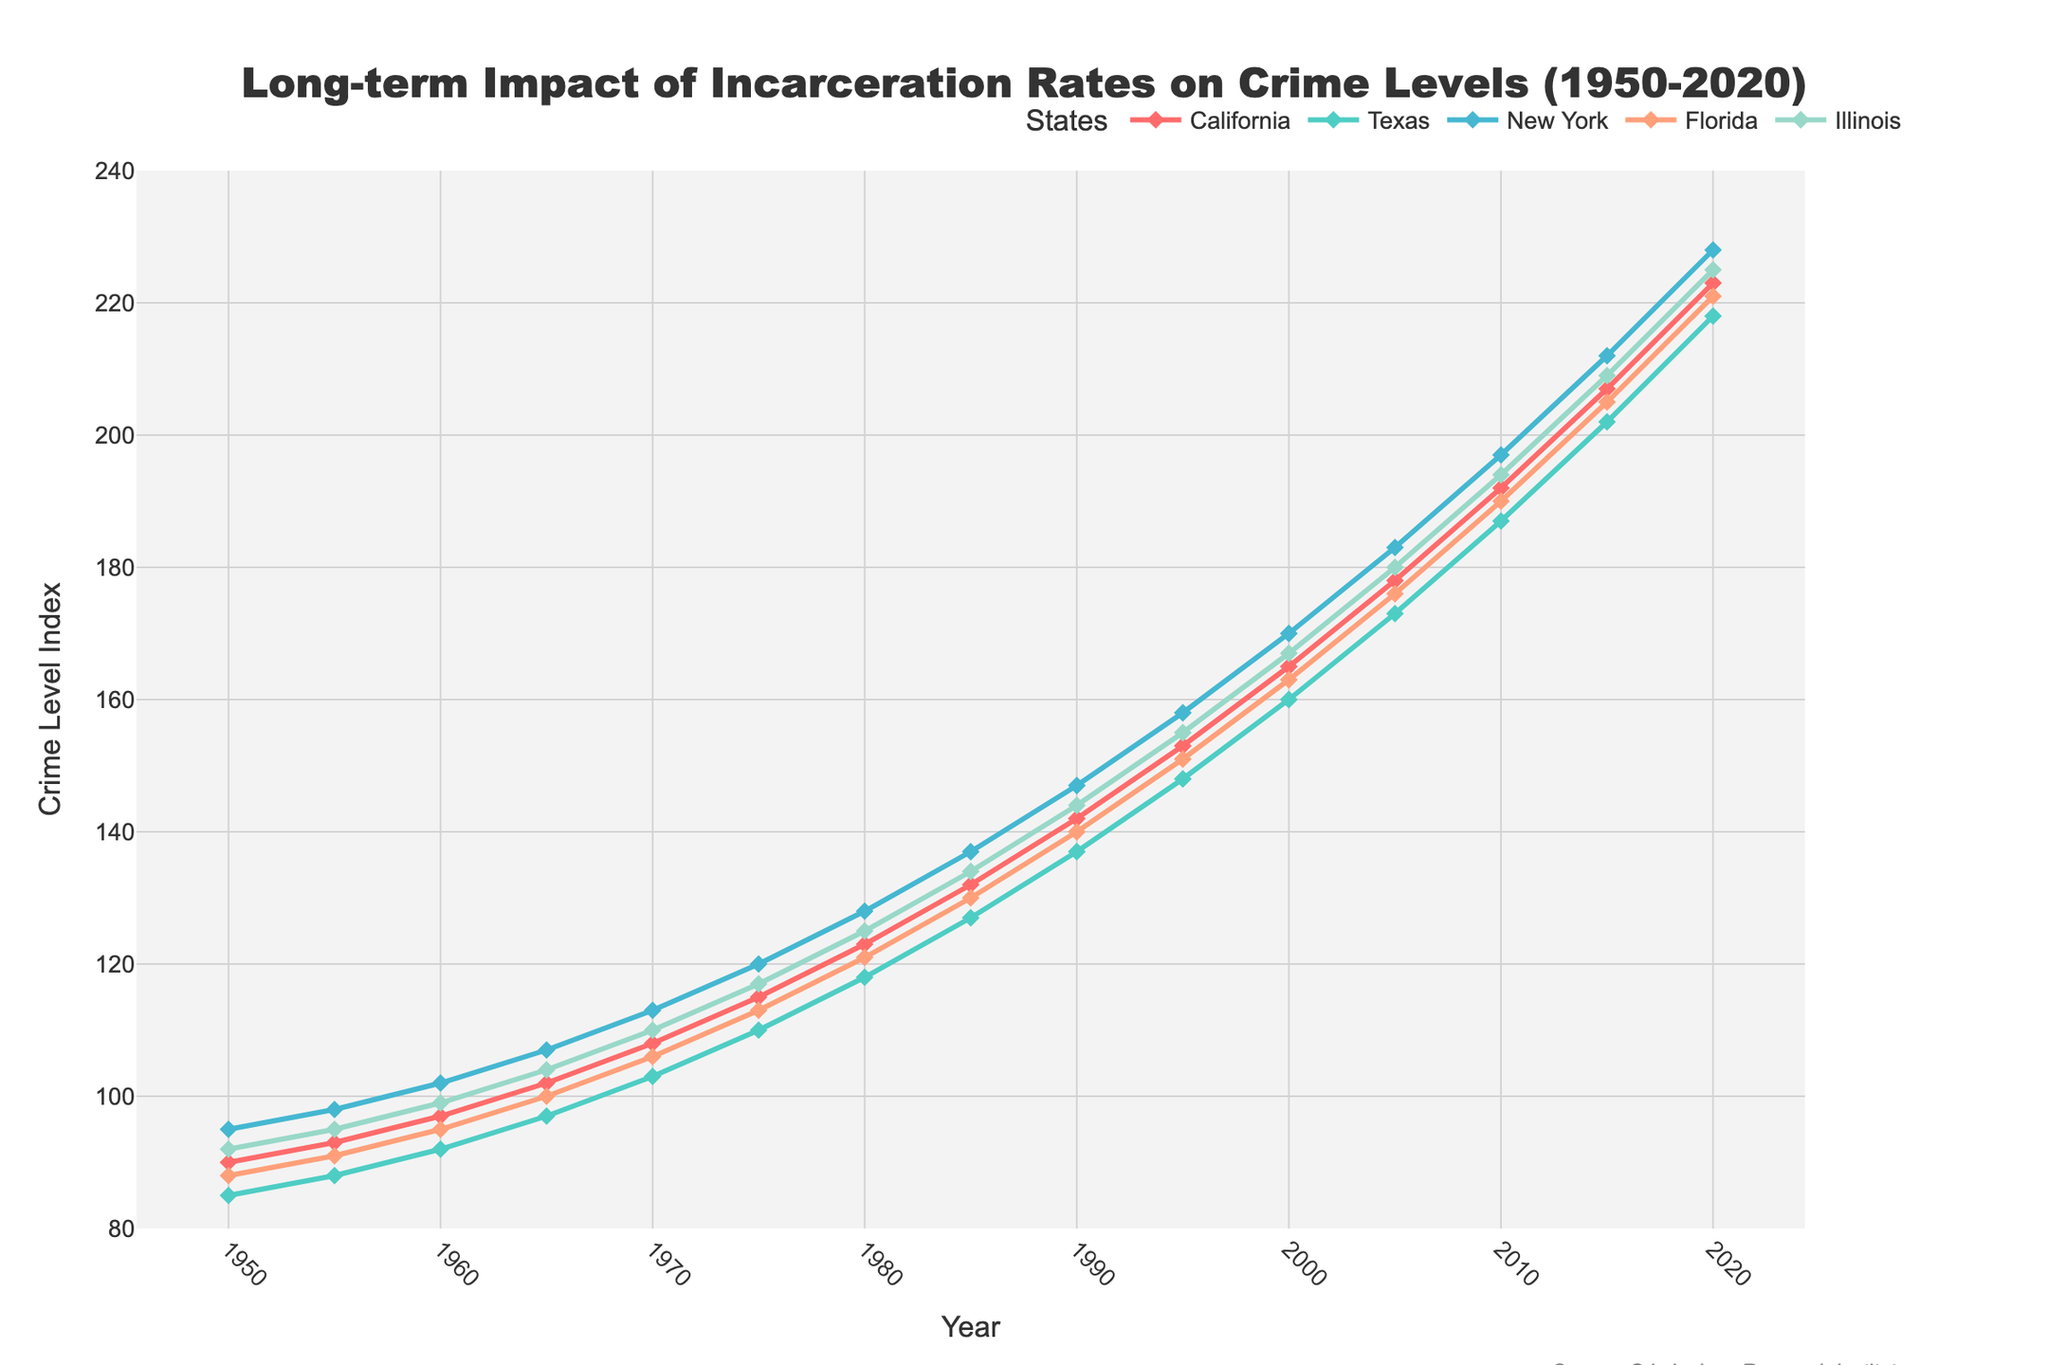What was the crime level in Texas in the year 2000? To determine the crime level in Texas in the year 2000, locate '2000' on the x-axis and find where the Texas line intersects this year. From the data, it intersects at 160.
Answer: 160 Which state had the highest increase in crime levels from 1950 to 2020? To find which state had the highest increase in crime levels, subtract the crime levels of each state in 1950 from the levels in 2020. The differences are: California (223-90=133), Texas (218-85=133), New York (228-95=133), Florida (221-88=133), Illinois (225-92=133). All states increased by the same amount, so multiple states tie.
Answer: California, Texas, New York, Florida, Illinois (tie) What is the average crime level across all states in 1980? To find the average crime level in 1980, sum the crime levels of all states in 1980 and divide by the number of states. The levels are: California (123), Texas (118), New York (128), Florida (121), Illinois (125). Sum: 123 + 118 + 128 + 121 + 125 = 615. Average: 615 / 5 = 123.
Answer: 123 Which state had the steeper increase in crime levels between 1965 and 1975, California or New York? To determine which state had a steeper increase, calculate the difference in crime levels between 1965 and 1975 for both states. California: 115 - 102 = 13. New York: 120 - 107 = 13. Both states had the same increase, so they had equal steepness.
Answer: Both equal What color represents Florida's crime level line? Identify the color of Florida's line in the legend of the chart. Florida is represented by an orange color.
Answer: Orange Compare the crime level trends between Illinois and New York from 1970 to 2020. Which state experienced more fluctuations? To compare the trends, observe the line patterns for Illinois and New York. New York’s line appears to have more fluctuations than Illinois's from 1970 to 2020, as New York has more distinct upward and downward movements.
Answer: New York What is the combined crime level for California and Texas in 1995? To find the combined crime level, add the crime levels of California and Texas in 1995. California: 153, Texas: 148. Combined: 153 + 148 = 301.
Answer: 301 Between the years 1985 and 2000, which state showed the least change in crime level? To determine the least change, find the difference in crime levels between 1985 and 2000 for each state. California: (165-132)=33, Texas: (160-127)=33, New York: (170-137)=33, Florida: (163-130)=33, Illinois: (167-134)=33. All states had the same change.
Answer: All states equal What is the difference between the highest and lowest crime levels in 2020 among the states? To find the difference, subtract the lowest crime level from the highest crime level in 2020. Highest: New York (228), Lowest: Texas (218). Difference: 228 - 218 = 10.
Answer: 10 